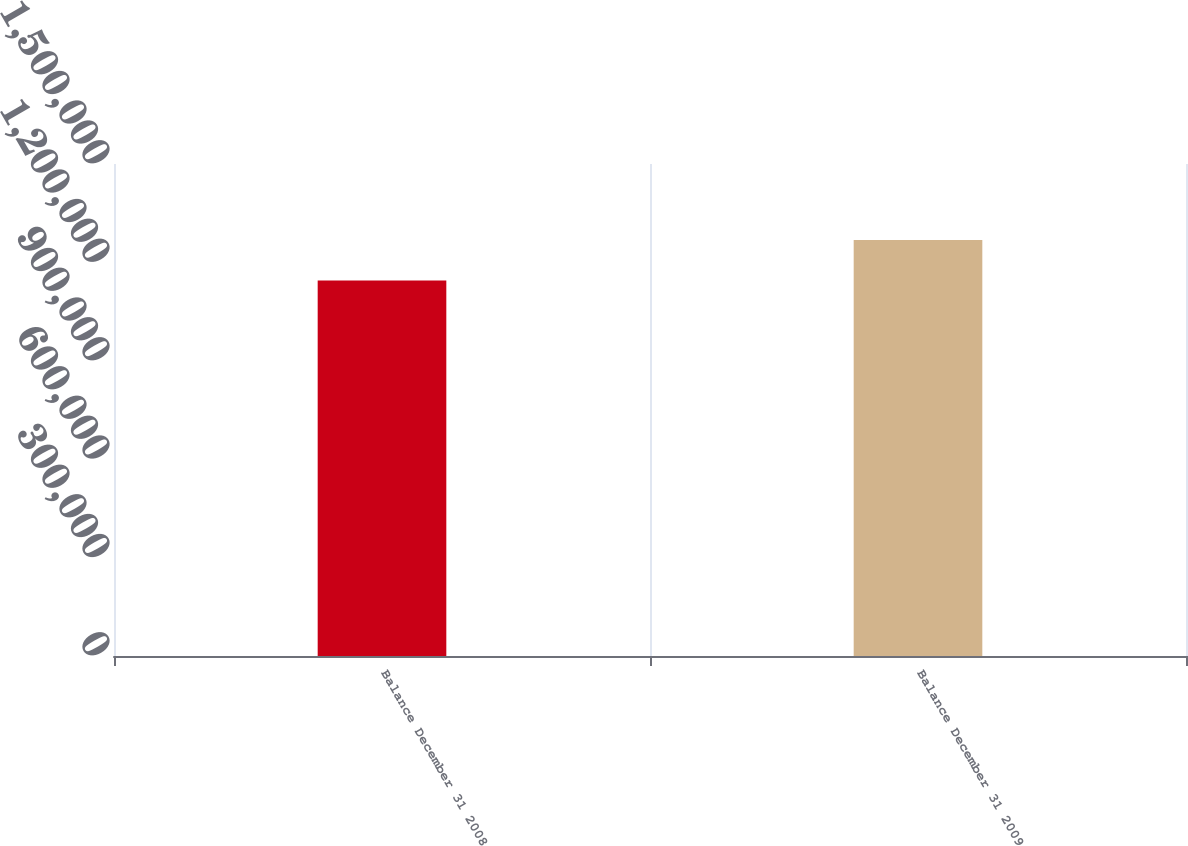<chart> <loc_0><loc_0><loc_500><loc_500><bar_chart><fcel>Balance December 31 2008<fcel>Balance December 31 2009<nl><fcel>1.14478e+06<fcel>1.2681e+06<nl></chart> 